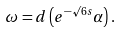<formula> <loc_0><loc_0><loc_500><loc_500>\omega = d \left ( e ^ { - \surd 6 s } \alpha \right ) .</formula> 